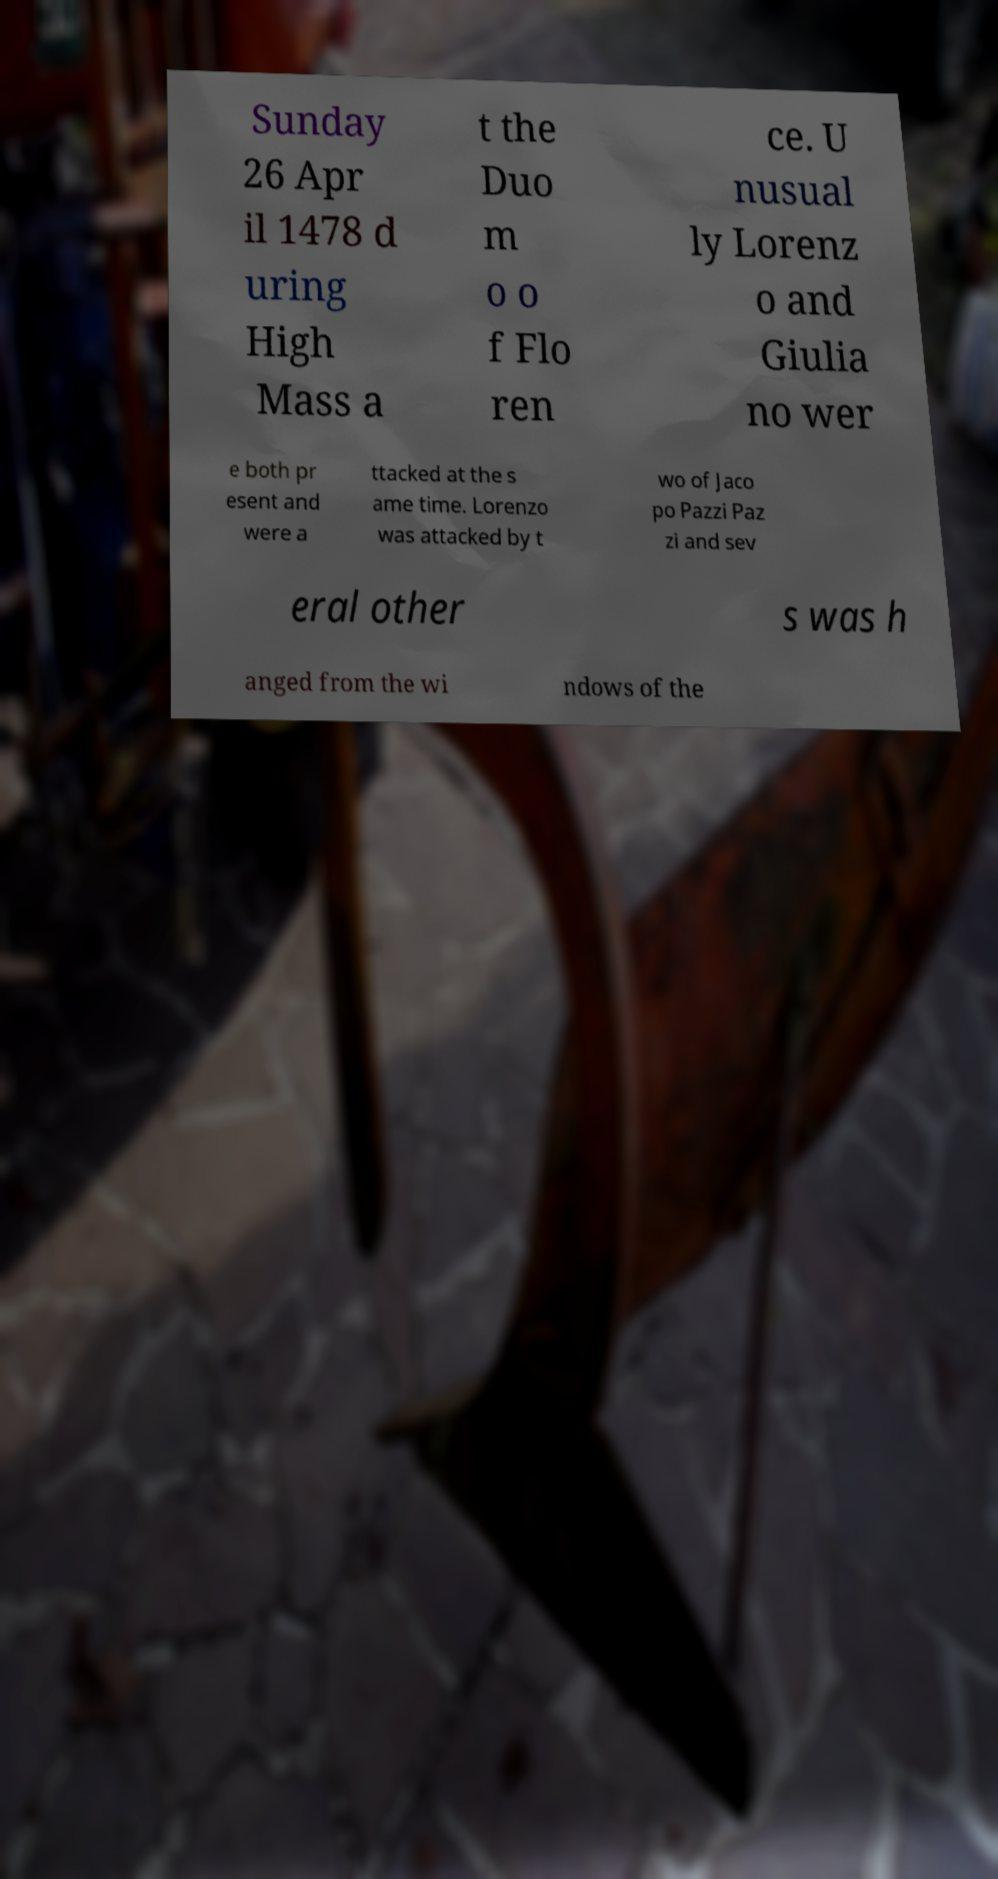What messages or text are displayed in this image? I need them in a readable, typed format. Sunday 26 Apr il 1478 d uring High Mass a t the Duo m o o f Flo ren ce. U nusual ly Lorenz o and Giulia no wer e both pr esent and were a ttacked at the s ame time. Lorenzo was attacked by t wo of Jaco po Pazzi Paz zi and sev eral other s was h anged from the wi ndows of the 